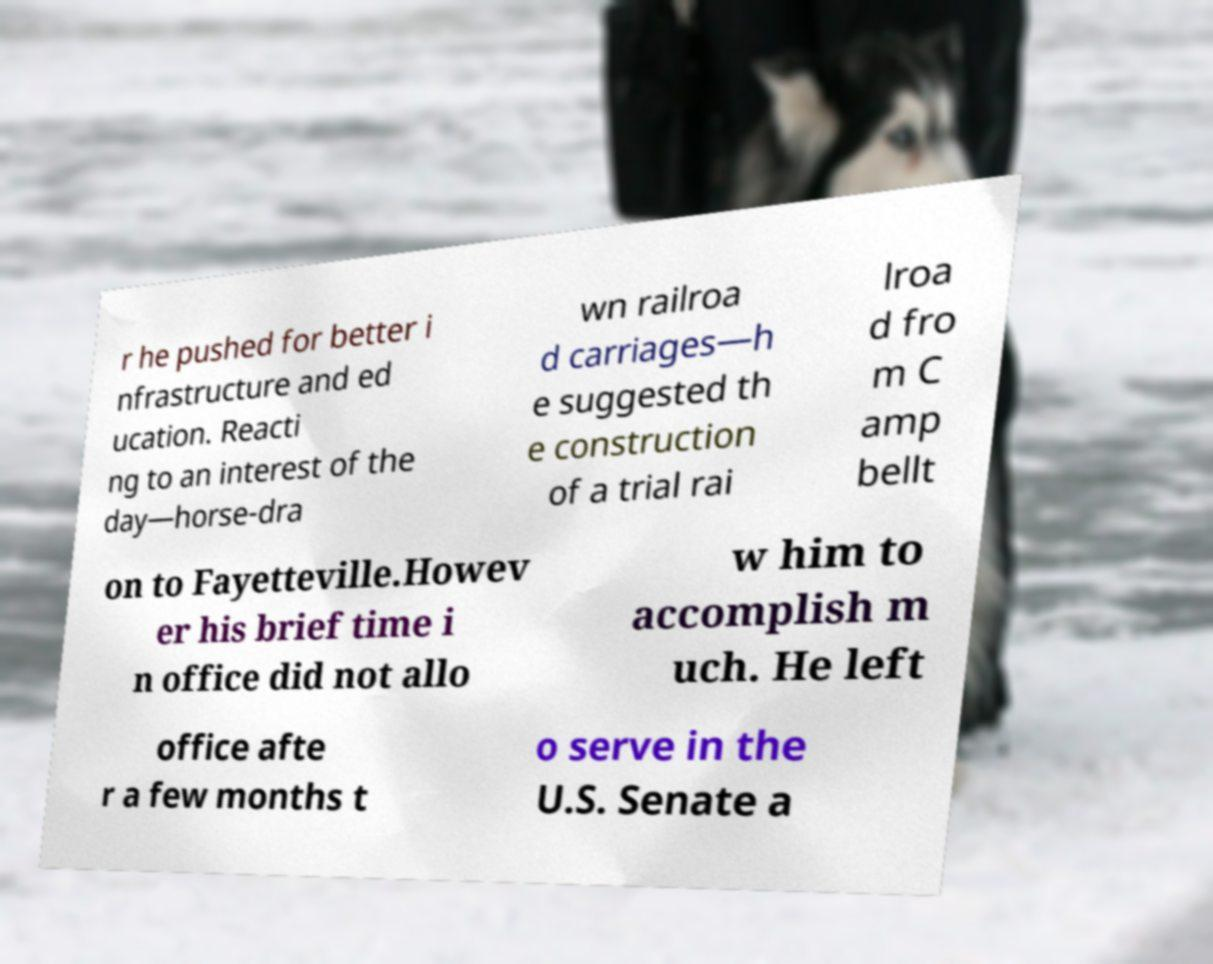What messages or text are displayed in this image? I need them in a readable, typed format. r he pushed for better i nfrastructure and ed ucation. Reacti ng to an interest of the day—horse-dra wn railroa d carriages—h e suggested th e construction of a trial rai lroa d fro m C amp bellt on to Fayetteville.Howev er his brief time i n office did not allo w him to accomplish m uch. He left office afte r a few months t o serve in the U.S. Senate a 